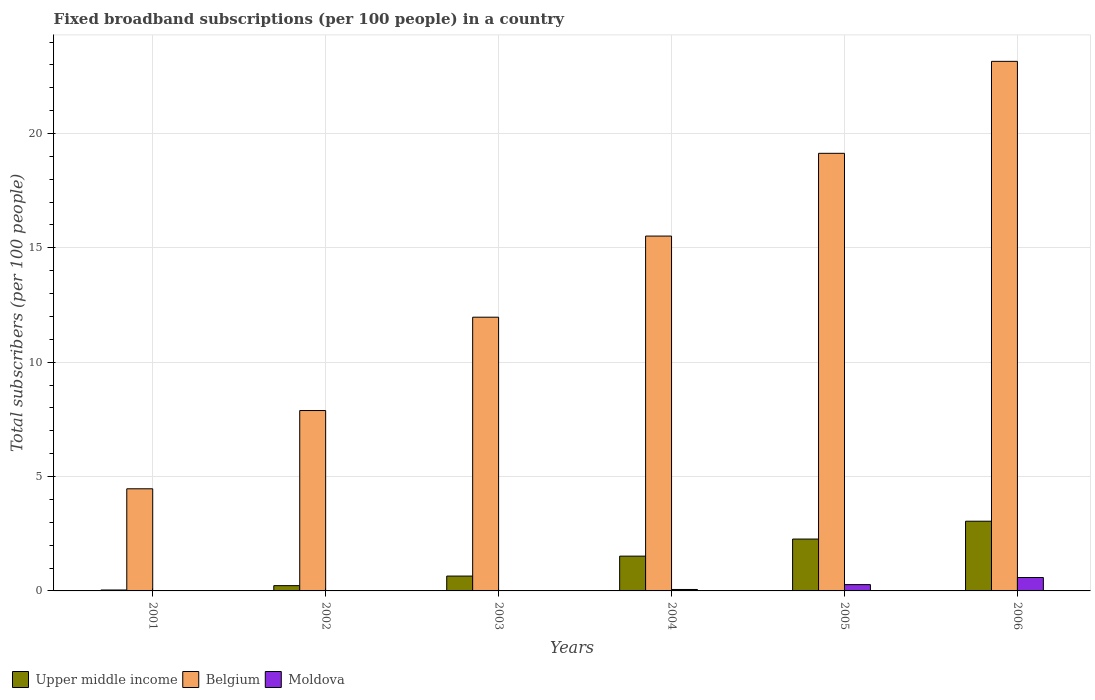Are the number of bars per tick equal to the number of legend labels?
Offer a very short reply. Yes. How many bars are there on the 3rd tick from the left?
Your response must be concise. 3. How many bars are there on the 4th tick from the right?
Provide a short and direct response. 3. What is the label of the 1st group of bars from the left?
Make the answer very short. 2001. In how many cases, is the number of bars for a given year not equal to the number of legend labels?
Make the answer very short. 0. What is the number of broadband subscriptions in Moldova in 2004?
Your response must be concise. 0.06. Across all years, what is the maximum number of broadband subscriptions in Upper middle income?
Your response must be concise. 3.05. Across all years, what is the minimum number of broadband subscriptions in Belgium?
Your response must be concise. 4.47. In which year was the number of broadband subscriptions in Upper middle income maximum?
Offer a very short reply. 2006. What is the total number of broadband subscriptions in Upper middle income in the graph?
Provide a short and direct response. 7.76. What is the difference between the number of broadband subscriptions in Moldova in 2001 and that in 2004?
Ensure brevity in your answer.  -0.06. What is the difference between the number of broadband subscriptions in Belgium in 2005 and the number of broadband subscriptions in Moldova in 2002?
Your response must be concise. 19.12. What is the average number of broadband subscriptions in Moldova per year?
Provide a short and direct response. 0.16. In the year 2004, what is the difference between the number of broadband subscriptions in Belgium and number of broadband subscriptions in Upper middle income?
Your answer should be compact. 13.99. In how many years, is the number of broadband subscriptions in Moldova greater than 11?
Your answer should be very brief. 0. What is the ratio of the number of broadband subscriptions in Belgium in 2002 to that in 2005?
Your response must be concise. 0.41. What is the difference between the highest and the second highest number of broadband subscriptions in Belgium?
Provide a short and direct response. 4.02. What is the difference between the highest and the lowest number of broadband subscriptions in Moldova?
Your answer should be very brief. 0.58. What does the 2nd bar from the left in 2001 represents?
Provide a short and direct response. Belgium. What does the 2nd bar from the right in 2005 represents?
Give a very brief answer. Belgium. Is it the case that in every year, the sum of the number of broadband subscriptions in Moldova and number of broadband subscriptions in Belgium is greater than the number of broadband subscriptions in Upper middle income?
Make the answer very short. Yes. How many bars are there?
Offer a terse response. 18. How many years are there in the graph?
Your answer should be compact. 6. What is the difference between two consecutive major ticks on the Y-axis?
Make the answer very short. 5. Are the values on the major ticks of Y-axis written in scientific E-notation?
Offer a very short reply. No. Does the graph contain any zero values?
Offer a very short reply. No. Does the graph contain grids?
Offer a very short reply. Yes. What is the title of the graph?
Your answer should be compact. Fixed broadband subscriptions (per 100 people) in a country. What is the label or title of the X-axis?
Provide a short and direct response. Years. What is the label or title of the Y-axis?
Your response must be concise. Total subscribers (per 100 people). What is the Total subscribers (per 100 people) in Upper middle income in 2001?
Ensure brevity in your answer.  0.04. What is the Total subscribers (per 100 people) in Belgium in 2001?
Make the answer very short. 4.47. What is the Total subscribers (per 100 people) of Moldova in 2001?
Ensure brevity in your answer.  0.01. What is the Total subscribers (per 100 people) in Upper middle income in 2002?
Your response must be concise. 0.23. What is the Total subscribers (per 100 people) in Belgium in 2002?
Make the answer very short. 7.89. What is the Total subscribers (per 100 people) in Moldova in 2002?
Offer a terse response. 0.01. What is the Total subscribers (per 100 people) of Upper middle income in 2003?
Ensure brevity in your answer.  0.65. What is the Total subscribers (per 100 people) of Belgium in 2003?
Provide a short and direct response. 11.97. What is the Total subscribers (per 100 people) of Moldova in 2003?
Your answer should be very brief. 0.02. What is the Total subscribers (per 100 people) in Upper middle income in 2004?
Offer a terse response. 1.52. What is the Total subscribers (per 100 people) in Belgium in 2004?
Provide a succinct answer. 15.52. What is the Total subscribers (per 100 people) in Moldova in 2004?
Provide a succinct answer. 0.06. What is the Total subscribers (per 100 people) in Upper middle income in 2005?
Your answer should be compact. 2.27. What is the Total subscribers (per 100 people) in Belgium in 2005?
Your answer should be very brief. 19.13. What is the Total subscribers (per 100 people) of Moldova in 2005?
Keep it short and to the point. 0.28. What is the Total subscribers (per 100 people) in Upper middle income in 2006?
Your response must be concise. 3.05. What is the Total subscribers (per 100 people) of Belgium in 2006?
Offer a very short reply. 23.15. What is the Total subscribers (per 100 people) of Moldova in 2006?
Your response must be concise. 0.59. Across all years, what is the maximum Total subscribers (per 100 people) of Upper middle income?
Provide a succinct answer. 3.05. Across all years, what is the maximum Total subscribers (per 100 people) in Belgium?
Provide a short and direct response. 23.15. Across all years, what is the maximum Total subscribers (per 100 people) of Moldova?
Offer a very short reply. 0.59. Across all years, what is the minimum Total subscribers (per 100 people) in Upper middle income?
Offer a terse response. 0.04. Across all years, what is the minimum Total subscribers (per 100 people) in Belgium?
Offer a terse response. 4.47. Across all years, what is the minimum Total subscribers (per 100 people) in Moldova?
Your answer should be compact. 0.01. What is the total Total subscribers (per 100 people) in Upper middle income in the graph?
Offer a very short reply. 7.76. What is the total Total subscribers (per 100 people) in Belgium in the graph?
Provide a short and direct response. 82.13. What is the total Total subscribers (per 100 people) in Moldova in the graph?
Offer a terse response. 0.96. What is the difference between the Total subscribers (per 100 people) in Upper middle income in 2001 and that in 2002?
Offer a terse response. -0.19. What is the difference between the Total subscribers (per 100 people) in Belgium in 2001 and that in 2002?
Your answer should be very brief. -3.42. What is the difference between the Total subscribers (per 100 people) in Moldova in 2001 and that in 2002?
Offer a terse response. -0. What is the difference between the Total subscribers (per 100 people) in Upper middle income in 2001 and that in 2003?
Offer a terse response. -0.61. What is the difference between the Total subscribers (per 100 people) in Belgium in 2001 and that in 2003?
Keep it short and to the point. -7.5. What is the difference between the Total subscribers (per 100 people) of Moldova in 2001 and that in 2003?
Your answer should be compact. -0.01. What is the difference between the Total subscribers (per 100 people) in Upper middle income in 2001 and that in 2004?
Offer a terse response. -1.48. What is the difference between the Total subscribers (per 100 people) of Belgium in 2001 and that in 2004?
Give a very brief answer. -11.05. What is the difference between the Total subscribers (per 100 people) in Moldova in 2001 and that in 2004?
Your response must be concise. -0.06. What is the difference between the Total subscribers (per 100 people) of Upper middle income in 2001 and that in 2005?
Ensure brevity in your answer.  -2.23. What is the difference between the Total subscribers (per 100 people) in Belgium in 2001 and that in 2005?
Provide a succinct answer. -14.67. What is the difference between the Total subscribers (per 100 people) in Moldova in 2001 and that in 2005?
Your response must be concise. -0.27. What is the difference between the Total subscribers (per 100 people) in Upper middle income in 2001 and that in 2006?
Your answer should be very brief. -3.01. What is the difference between the Total subscribers (per 100 people) in Belgium in 2001 and that in 2006?
Ensure brevity in your answer.  -18.69. What is the difference between the Total subscribers (per 100 people) in Moldova in 2001 and that in 2006?
Your answer should be very brief. -0.58. What is the difference between the Total subscribers (per 100 people) of Upper middle income in 2002 and that in 2003?
Offer a terse response. -0.42. What is the difference between the Total subscribers (per 100 people) of Belgium in 2002 and that in 2003?
Your response must be concise. -4.08. What is the difference between the Total subscribers (per 100 people) in Moldova in 2002 and that in 2003?
Make the answer very short. -0. What is the difference between the Total subscribers (per 100 people) of Upper middle income in 2002 and that in 2004?
Provide a short and direct response. -1.29. What is the difference between the Total subscribers (per 100 people) of Belgium in 2002 and that in 2004?
Make the answer very short. -7.63. What is the difference between the Total subscribers (per 100 people) in Moldova in 2002 and that in 2004?
Provide a succinct answer. -0.05. What is the difference between the Total subscribers (per 100 people) in Upper middle income in 2002 and that in 2005?
Keep it short and to the point. -2.04. What is the difference between the Total subscribers (per 100 people) in Belgium in 2002 and that in 2005?
Provide a short and direct response. -11.25. What is the difference between the Total subscribers (per 100 people) of Moldova in 2002 and that in 2005?
Your answer should be compact. -0.27. What is the difference between the Total subscribers (per 100 people) in Upper middle income in 2002 and that in 2006?
Your response must be concise. -2.82. What is the difference between the Total subscribers (per 100 people) in Belgium in 2002 and that in 2006?
Your answer should be very brief. -15.27. What is the difference between the Total subscribers (per 100 people) in Moldova in 2002 and that in 2006?
Your answer should be compact. -0.58. What is the difference between the Total subscribers (per 100 people) in Upper middle income in 2003 and that in 2004?
Provide a short and direct response. -0.87. What is the difference between the Total subscribers (per 100 people) in Belgium in 2003 and that in 2004?
Provide a short and direct response. -3.55. What is the difference between the Total subscribers (per 100 people) in Moldova in 2003 and that in 2004?
Provide a short and direct response. -0.05. What is the difference between the Total subscribers (per 100 people) of Upper middle income in 2003 and that in 2005?
Your answer should be compact. -1.62. What is the difference between the Total subscribers (per 100 people) of Belgium in 2003 and that in 2005?
Your response must be concise. -7.17. What is the difference between the Total subscribers (per 100 people) of Moldova in 2003 and that in 2005?
Ensure brevity in your answer.  -0.26. What is the difference between the Total subscribers (per 100 people) in Upper middle income in 2003 and that in 2006?
Provide a succinct answer. -2.4. What is the difference between the Total subscribers (per 100 people) in Belgium in 2003 and that in 2006?
Ensure brevity in your answer.  -11.19. What is the difference between the Total subscribers (per 100 people) of Moldova in 2003 and that in 2006?
Make the answer very short. -0.57. What is the difference between the Total subscribers (per 100 people) in Upper middle income in 2004 and that in 2005?
Offer a very short reply. -0.75. What is the difference between the Total subscribers (per 100 people) of Belgium in 2004 and that in 2005?
Offer a very short reply. -3.62. What is the difference between the Total subscribers (per 100 people) of Moldova in 2004 and that in 2005?
Offer a very short reply. -0.21. What is the difference between the Total subscribers (per 100 people) of Upper middle income in 2004 and that in 2006?
Offer a terse response. -1.53. What is the difference between the Total subscribers (per 100 people) in Belgium in 2004 and that in 2006?
Give a very brief answer. -7.64. What is the difference between the Total subscribers (per 100 people) in Moldova in 2004 and that in 2006?
Make the answer very short. -0.52. What is the difference between the Total subscribers (per 100 people) in Upper middle income in 2005 and that in 2006?
Provide a succinct answer. -0.78. What is the difference between the Total subscribers (per 100 people) of Belgium in 2005 and that in 2006?
Give a very brief answer. -4.02. What is the difference between the Total subscribers (per 100 people) in Moldova in 2005 and that in 2006?
Your response must be concise. -0.31. What is the difference between the Total subscribers (per 100 people) in Upper middle income in 2001 and the Total subscribers (per 100 people) in Belgium in 2002?
Keep it short and to the point. -7.85. What is the difference between the Total subscribers (per 100 people) of Upper middle income in 2001 and the Total subscribers (per 100 people) of Moldova in 2002?
Ensure brevity in your answer.  0.03. What is the difference between the Total subscribers (per 100 people) of Belgium in 2001 and the Total subscribers (per 100 people) of Moldova in 2002?
Give a very brief answer. 4.46. What is the difference between the Total subscribers (per 100 people) of Upper middle income in 2001 and the Total subscribers (per 100 people) of Belgium in 2003?
Offer a terse response. -11.93. What is the difference between the Total subscribers (per 100 people) in Upper middle income in 2001 and the Total subscribers (per 100 people) in Moldova in 2003?
Your response must be concise. 0.03. What is the difference between the Total subscribers (per 100 people) in Belgium in 2001 and the Total subscribers (per 100 people) in Moldova in 2003?
Provide a short and direct response. 4.45. What is the difference between the Total subscribers (per 100 people) in Upper middle income in 2001 and the Total subscribers (per 100 people) in Belgium in 2004?
Your response must be concise. -15.47. What is the difference between the Total subscribers (per 100 people) in Upper middle income in 2001 and the Total subscribers (per 100 people) in Moldova in 2004?
Keep it short and to the point. -0.02. What is the difference between the Total subscribers (per 100 people) in Belgium in 2001 and the Total subscribers (per 100 people) in Moldova in 2004?
Offer a terse response. 4.4. What is the difference between the Total subscribers (per 100 people) of Upper middle income in 2001 and the Total subscribers (per 100 people) of Belgium in 2005?
Provide a succinct answer. -19.09. What is the difference between the Total subscribers (per 100 people) of Upper middle income in 2001 and the Total subscribers (per 100 people) of Moldova in 2005?
Offer a very short reply. -0.24. What is the difference between the Total subscribers (per 100 people) in Belgium in 2001 and the Total subscribers (per 100 people) in Moldova in 2005?
Give a very brief answer. 4.19. What is the difference between the Total subscribers (per 100 people) in Upper middle income in 2001 and the Total subscribers (per 100 people) in Belgium in 2006?
Offer a very short reply. -23.11. What is the difference between the Total subscribers (per 100 people) of Upper middle income in 2001 and the Total subscribers (per 100 people) of Moldova in 2006?
Ensure brevity in your answer.  -0.55. What is the difference between the Total subscribers (per 100 people) in Belgium in 2001 and the Total subscribers (per 100 people) in Moldova in 2006?
Provide a short and direct response. 3.88. What is the difference between the Total subscribers (per 100 people) of Upper middle income in 2002 and the Total subscribers (per 100 people) of Belgium in 2003?
Provide a succinct answer. -11.74. What is the difference between the Total subscribers (per 100 people) in Upper middle income in 2002 and the Total subscribers (per 100 people) in Moldova in 2003?
Offer a very short reply. 0.22. What is the difference between the Total subscribers (per 100 people) of Belgium in 2002 and the Total subscribers (per 100 people) of Moldova in 2003?
Keep it short and to the point. 7.87. What is the difference between the Total subscribers (per 100 people) of Upper middle income in 2002 and the Total subscribers (per 100 people) of Belgium in 2004?
Your response must be concise. -15.28. What is the difference between the Total subscribers (per 100 people) of Upper middle income in 2002 and the Total subscribers (per 100 people) of Moldova in 2004?
Your answer should be compact. 0.17. What is the difference between the Total subscribers (per 100 people) of Belgium in 2002 and the Total subscribers (per 100 people) of Moldova in 2004?
Provide a succinct answer. 7.82. What is the difference between the Total subscribers (per 100 people) in Upper middle income in 2002 and the Total subscribers (per 100 people) in Belgium in 2005?
Keep it short and to the point. -18.9. What is the difference between the Total subscribers (per 100 people) of Upper middle income in 2002 and the Total subscribers (per 100 people) of Moldova in 2005?
Provide a succinct answer. -0.05. What is the difference between the Total subscribers (per 100 people) in Belgium in 2002 and the Total subscribers (per 100 people) in Moldova in 2005?
Your response must be concise. 7.61. What is the difference between the Total subscribers (per 100 people) in Upper middle income in 2002 and the Total subscribers (per 100 people) in Belgium in 2006?
Give a very brief answer. -22.92. What is the difference between the Total subscribers (per 100 people) of Upper middle income in 2002 and the Total subscribers (per 100 people) of Moldova in 2006?
Your answer should be very brief. -0.36. What is the difference between the Total subscribers (per 100 people) in Belgium in 2002 and the Total subscribers (per 100 people) in Moldova in 2006?
Your answer should be compact. 7.3. What is the difference between the Total subscribers (per 100 people) in Upper middle income in 2003 and the Total subscribers (per 100 people) in Belgium in 2004?
Your answer should be very brief. -14.87. What is the difference between the Total subscribers (per 100 people) in Upper middle income in 2003 and the Total subscribers (per 100 people) in Moldova in 2004?
Your answer should be very brief. 0.59. What is the difference between the Total subscribers (per 100 people) in Belgium in 2003 and the Total subscribers (per 100 people) in Moldova in 2004?
Provide a short and direct response. 11.91. What is the difference between the Total subscribers (per 100 people) of Upper middle income in 2003 and the Total subscribers (per 100 people) of Belgium in 2005?
Provide a short and direct response. -18.48. What is the difference between the Total subscribers (per 100 people) of Upper middle income in 2003 and the Total subscribers (per 100 people) of Moldova in 2005?
Provide a succinct answer. 0.37. What is the difference between the Total subscribers (per 100 people) in Belgium in 2003 and the Total subscribers (per 100 people) in Moldova in 2005?
Your answer should be very brief. 11.69. What is the difference between the Total subscribers (per 100 people) of Upper middle income in 2003 and the Total subscribers (per 100 people) of Belgium in 2006?
Offer a terse response. -22.51. What is the difference between the Total subscribers (per 100 people) in Upper middle income in 2003 and the Total subscribers (per 100 people) in Moldova in 2006?
Ensure brevity in your answer.  0.06. What is the difference between the Total subscribers (per 100 people) in Belgium in 2003 and the Total subscribers (per 100 people) in Moldova in 2006?
Give a very brief answer. 11.38. What is the difference between the Total subscribers (per 100 people) of Upper middle income in 2004 and the Total subscribers (per 100 people) of Belgium in 2005?
Give a very brief answer. -17.61. What is the difference between the Total subscribers (per 100 people) in Upper middle income in 2004 and the Total subscribers (per 100 people) in Moldova in 2005?
Your answer should be compact. 1.25. What is the difference between the Total subscribers (per 100 people) of Belgium in 2004 and the Total subscribers (per 100 people) of Moldova in 2005?
Give a very brief answer. 15.24. What is the difference between the Total subscribers (per 100 people) of Upper middle income in 2004 and the Total subscribers (per 100 people) of Belgium in 2006?
Keep it short and to the point. -21.63. What is the difference between the Total subscribers (per 100 people) in Upper middle income in 2004 and the Total subscribers (per 100 people) in Moldova in 2006?
Your answer should be compact. 0.93. What is the difference between the Total subscribers (per 100 people) of Belgium in 2004 and the Total subscribers (per 100 people) of Moldova in 2006?
Offer a terse response. 14.93. What is the difference between the Total subscribers (per 100 people) of Upper middle income in 2005 and the Total subscribers (per 100 people) of Belgium in 2006?
Ensure brevity in your answer.  -20.89. What is the difference between the Total subscribers (per 100 people) of Upper middle income in 2005 and the Total subscribers (per 100 people) of Moldova in 2006?
Keep it short and to the point. 1.68. What is the difference between the Total subscribers (per 100 people) in Belgium in 2005 and the Total subscribers (per 100 people) in Moldova in 2006?
Your answer should be very brief. 18.55. What is the average Total subscribers (per 100 people) in Upper middle income per year?
Make the answer very short. 1.29. What is the average Total subscribers (per 100 people) of Belgium per year?
Offer a very short reply. 13.69. What is the average Total subscribers (per 100 people) of Moldova per year?
Provide a short and direct response. 0.16. In the year 2001, what is the difference between the Total subscribers (per 100 people) in Upper middle income and Total subscribers (per 100 people) in Belgium?
Give a very brief answer. -4.42. In the year 2001, what is the difference between the Total subscribers (per 100 people) in Upper middle income and Total subscribers (per 100 people) in Moldova?
Offer a terse response. 0.03. In the year 2001, what is the difference between the Total subscribers (per 100 people) in Belgium and Total subscribers (per 100 people) in Moldova?
Provide a succinct answer. 4.46. In the year 2002, what is the difference between the Total subscribers (per 100 people) of Upper middle income and Total subscribers (per 100 people) of Belgium?
Offer a very short reply. -7.66. In the year 2002, what is the difference between the Total subscribers (per 100 people) in Upper middle income and Total subscribers (per 100 people) in Moldova?
Your answer should be compact. 0.22. In the year 2002, what is the difference between the Total subscribers (per 100 people) of Belgium and Total subscribers (per 100 people) of Moldova?
Offer a very short reply. 7.88. In the year 2003, what is the difference between the Total subscribers (per 100 people) of Upper middle income and Total subscribers (per 100 people) of Belgium?
Your answer should be compact. -11.32. In the year 2003, what is the difference between the Total subscribers (per 100 people) in Upper middle income and Total subscribers (per 100 people) in Moldova?
Provide a succinct answer. 0.63. In the year 2003, what is the difference between the Total subscribers (per 100 people) in Belgium and Total subscribers (per 100 people) in Moldova?
Give a very brief answer. 11.95. In the year 2004, what is the difference between the Total subscribers (per 100 people) of Upper middle income and Total subscribers (per 100 people) of Belgium?
Offer a very short reply. -13.99. In the year 2004, what is the difference between the Total subscribers (per 100 people) in Upper middle income and Total subscribers (per 100 people) in Moldova?
Make the answer very short. 1.46. In the year 2004, what is the difference between the Total subscribers (per 100 people) in Belgium and Total subscribers (per 100 people) in Moldova?
Provide a succinct answer. 15.45. In the year 2005, what is the difference between the Total subscribers (per 100 people) of Upper middle income and Total subscribers (per 100 people) of Belgium?
Your answer should be very brief. -16.87. In the year 2005, what is the difference between the Total subscribers (per 100 people) in Upper middle income and Total subscribers (per 100 people) in Moldova?
Your response must be concise. 1.99. In the year 2005, what is the difference between the Total subscribers (per 100 people) in Belgium and Total subscribers (per 100 people) in Moldova?
Your answer should be compact. 18.86. In the year 2006, what is the difference between the Total subscribers (per 100 people) of Upper middle income and Total subscribers (per 100 people) of Belgium?
Keep it short and to the point. -20.11. In the year 2006, what is the difference between the Total subscribers (per 100 people) of Upper middle income and Total subscribers (per 100 people) of Moldova?
Give a very brief answer. 2.46. In the year 2006, what is the difference between the Total subscribers (per 100 people) of Belgium and Total subscribers (per 100 people) of Moldova?
Your response must be concise. 22.57. What is the ratio of the Total subscribers (per 100 people) in Upper middle income in 2001 to that in 2002?
Ensure brevity in your answer.  0.18. What is the ratio of the Total subscribers (per 100 people) in Belgium in 2001 to that in 2002?
Offer a terse response. 0.57. What is the ratio of the Total subscribers (per 100 people) of Moldova in 2001 to that in 2002?
Offer a very short reply. 0.56. What is the ratio of the Total subscribers (per 100 people) of Upper middle income in 2001 to that in 2003?
Provide a succinct answer. 0.06. What is the ratio of the Total subscribers (per 100 people) of Belgium in 2001 to that in 2003?
Make the answer very short. 0.37. What is the ratio of the Total subscribers (per 100 people) in Moldova in 2001 to that in 2003?
Ensure brevity in your answer.  0.39. What is the ratio of the Total subscribers (per 100 people) in Upper middle income in 2001 to that in 2004?
Ensure brevity in your answer.  0.03. What is the ratio of the Total subscribers (per 100 people) in Belgium in 2001 to that in 2004?
Keep it short and to the point. 0.29. What is the ratio of the Total subscribers (per 100 people) of Moldova in 2001 to that in 2004?
Offer a terse response. 0.09. What is the ratio of the Total subscribers (per 100 people) in Upper middle income in 2001 to that in 2005?
Your answer should be very brief. 0.02. What is the ratio of the Total subscribers (per 100 people) of Belgium in 2001 to that in 2005?
Offer a terse response. 0.23. What is the ratio of the Total subscribers (per 100 people) of Moldova in 2001 to that in 2005?
Provide a succinct answer. 0.02. What is the ratio of the Total subscribers (per 100 people) in Upper middle income in 2001 to that in 2006?
Keep it short and to the point. 0.01. What is the ratio of the Total subscribers (per 100 people) of Belgium in 2001 to that in 2006?
Your answer should be compact. 0.19. What is the ratio of the Total subscribers (per 100 people) of Moldova in 2001 to that in 2006?
Your response must be concise. 0.01. What is the ratio of the Total subscribers (per 100 people) in Upper middle income in 2002 to that in 2003?
Your answer should be very brief. 0.35. What is the ratio of the Total subscribers (per 100 people) in Belgium in 2002 to that in 2003?
Provide a succinct answer. 0.66. What is the ratio of the Total subscribers (per 100 people) in Moldova in 2002 to that in 2003?
Your answer should be very brief. 0.69. What is the ratio of the Total subscribers (per 100 people) of Upper middle income in 2002 to that in 2004?
Your answer should be very brief. 0.15. What is the ratio of the Total subscribers (per 100 people) of Belgium in 2002 to that in 2004?
Your response must be concise. 0.51. What is the ratio of the Total subscribers (per 100 people) of Moldova in 2002 to that in 2004?
Your response must be concise. 0.17. What is the ratio of the Total subscribers (per 100 people) of Upper middle income in 2002 to that in 2005?
Offer a very short reply. 0.1. What is the ratio of the Total subscribers (per 100 people) of Belgium in 2002 to that in 2005?
Your answer should be compact. 0.41. What is the ratio of the Total subscribers (per 100 people) of Moldova in 2002 to that in 2005?
Your answer should be compact. 0.04. What is the ratio of the Total subscribers (per 100 people) in Upper middle income in 2002 to that in 2006?
Your answer should be compact. 0.08. What is the ratio of the Total subscribers (per 100 people) of Belgium in 2002 to that in 2006?
Make the answer very short. 0.34. What is the ratio of the Total subscribers (per 100 people) in Moldova in 2002 to that in 2006?
Offer a very short reply. 0.02. What is the ratio of the Total subscribers (per 100 people) of Upper middle income in 2003 to that in 2004?
Your response must be concise. 0.43. What is the ratio of the Total subscribers (per 100 people) of Belgium in 2003 to that in 2004?
Your answer should be compact. 0.77. What is the ratio of the Total subscribers (per 100 people) in Moldova in 2003 to that in 2004?
Ensure brevity in your answer.  0.24. What is the ratio of the Total subscribers (per 100 people) in Upper middle income in 2003 to that in 2005?
Keep it short and to the point. 0.29. What is the ratio of the Total subscribers (per 100 people) in Belgium in 2003 to that in 2005?
Provide a short and direct response. 0.63. What is the ratio of the Total subscribers (per 100 people) of Moldova in 2003 to that in 2005?
Provide a short and direct response. 0.06. What is the ratio of the Total subscribers (per 100 people) in Upper middle income in 2003 to that in 2006?
Offer a terse response. 0.21. What is the ratio of the Total subscribers (per 100 people) in Belgium in 2003 to that in 2006?
Your response must be concise. 0.52. What is the ratio of the Total subscribers (per 100 people) in Moldova in 2003 to that in 2006?
Your response must be concise. 0.03. What is the ratio of the Total subscribers (per 100 people) of Upper middle income in 2004 to that in 2005?
Give a very brief answer. 0.67. What is the ratio of the Total subscribers (per 100 people) of Belgium in 2004 to that in 2005?
Provide a short and direct response. 0.81. What is the ratio of the Total subscribers (per 100 people) of Moldova in 2004 to that in 2005?
Your answer should be compact. 0.23. What is the ratio of the Total subscribers (per 100 people) of Upper middle income in 2004 to that in 2006?
Your response must be concise. 0.5. What is the ratio of the Total subscribers (per 100 people) in Belgium in 2004 to that in 2006?
Your answer should be very brief. 0.67. What is the ratio of the Total subscribers (per 100 people) in Moldova in 2004 to that in 2006?
Offer a very short reply. 0.11. What is the ratio of the Total subscribers (per 100 people) of Upper middle income in 2005 to that in 2006?
Ensure brevity in your answer.  0.74. What is the ratio of the Total subscribers (per 100 people) in Belgium in 2005 to that in 2006?
Your answer should be very brief. 0.83. What is the ratio of the Total subscribers (per 100 people) of Moldova in 2005 to that in 2006?
Offer a very short reply. 0.47. What is the difference between the highest and the second highest Total subscribers (per 100 people) of Upper middle income?
Make the answer very short. 0.78. What is the difference between the highest and the second highest Total subscribers (per 100 people) of Belgium?
Give a very brief answer. 4.02. What is the difference between the highest and the second highest Total subscribers (per 100 people) in Moldova?
Offer a very short reply. 0.31. What is the difference between the highest and the lowest Total subscribers (per 100 people) in Upper middle income?
Offer a terse response. 3.01. What is the difference between the highest and the lowest Total subscribers (per 100 people) in Belgium?
Provide a succinct answer. 18.69. What is the difference between the highest and the lowest Total subscribers (per 100 people) of Moldova?
Your response must be concise. 0.58. 